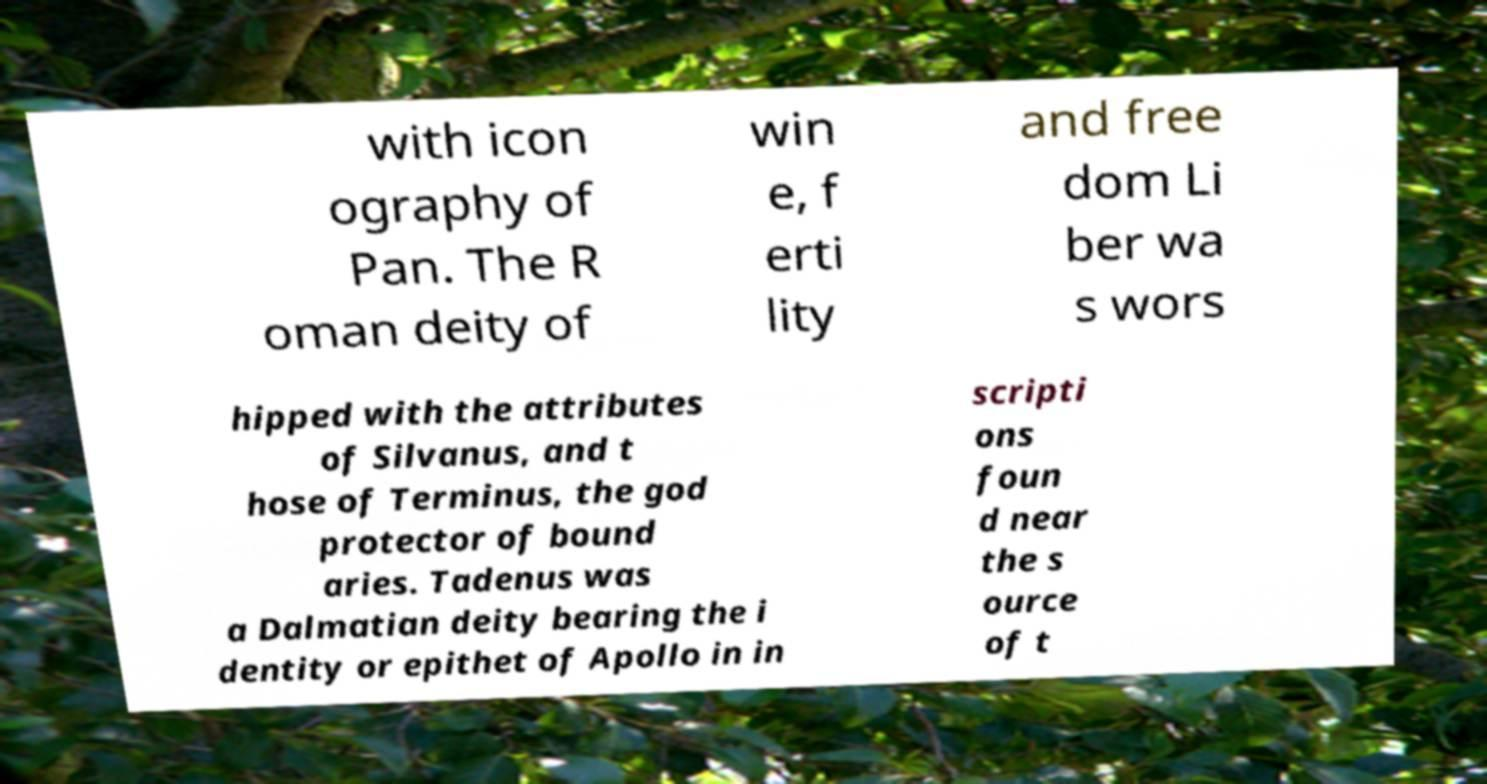Can you accurately transcribe the text from the provided image for me? with icon ography of Pan. The R oman deity of win e, f erti lity and free dom Li ber wa s wors hipped with the attributes of Silvanus, and t hose of Terminus, the god protector of bound aries. Tadenus was a Dalmatian deity bearing the i dentity or epithet of Apollo in in scripti ons foun d near the s ource of t 